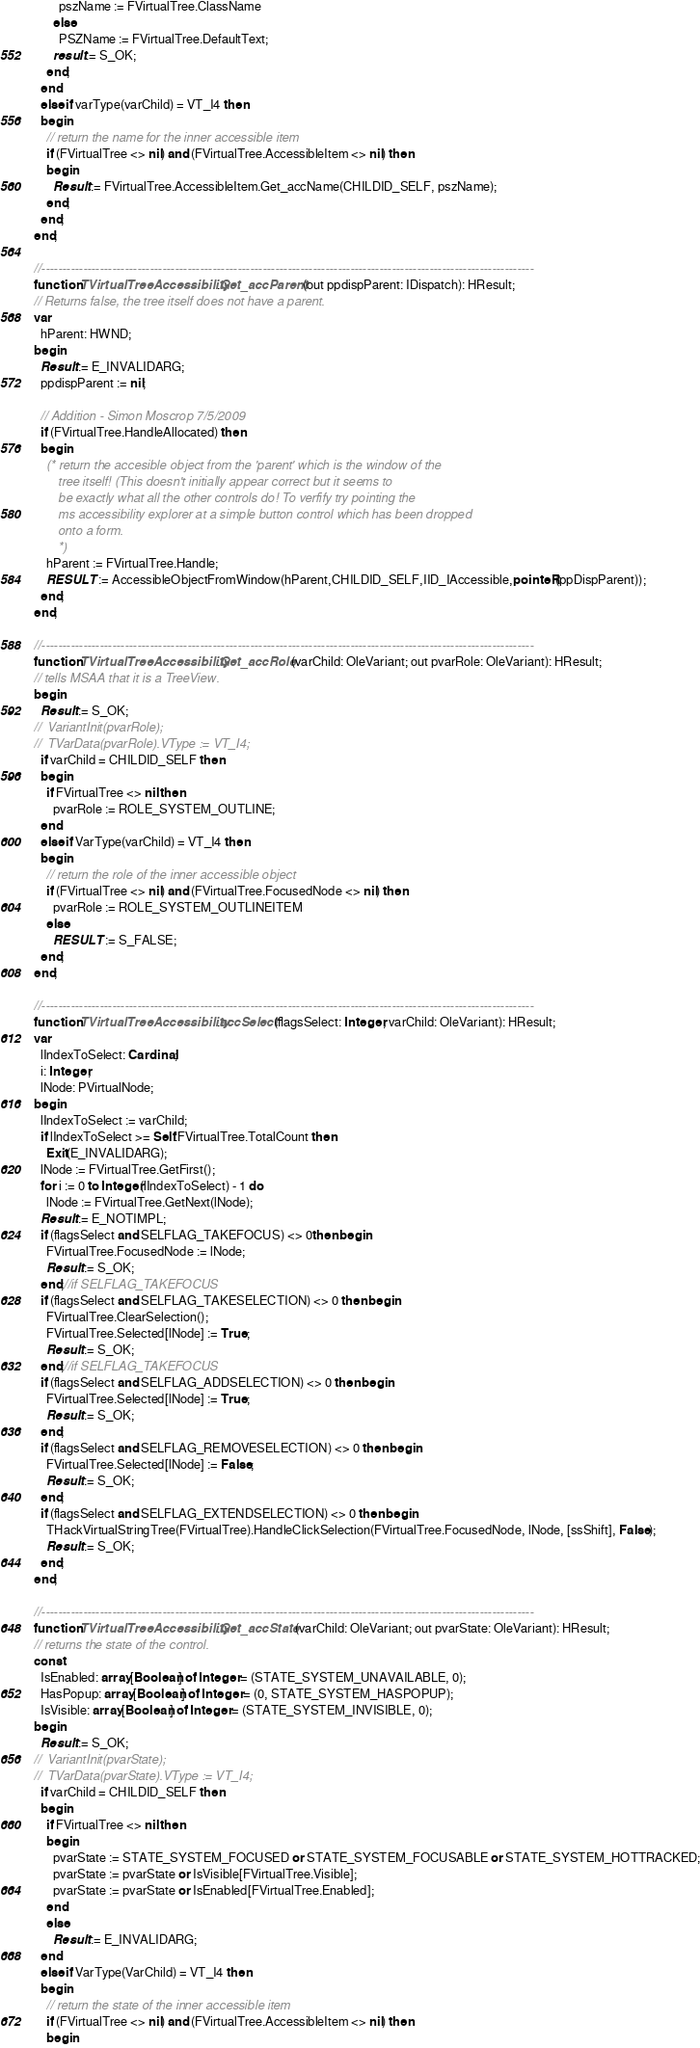<code> <loc_0><loc_0><loc_500><loc_500><_Pascal_>        pszName := FVirtualTree.ClassName
      else
        PSZName := FVirtualTree.DefaultText;
      result := S_OK;
    end;
  end
  else if varType(varChild) = VT_I4 then
  begin
    // return the name for the inner accessible item
    if (FVirtualTree <> nil) and (FVirtualTree.AccessibleItem <> nil) then
    begin
      Result := FVirtualTree.AccessibleItem.Get_accName(CHILDID_SELF, pszName);
    end;
  end;
end;

//----------------------------------------------------------------------------------------------------------------------
function TVirtualTreeAccessibility.Get_accParent(out ppdispParent: IDispatch): HResult;
// Returns false, the tree itself does not have a parent.
var
  hParent: HWND;
begin
  Result := E_INVALIDARG;
  ppdispParent := nil;

  // Addition - Simon Moscrop 7/5/2009
  if (FVirtualTree.HandleAllocated) then
  begin
    (* return the accesible object from the 'parent' which is the window of the
       tree itself! (This doesn't initially appear correct but it seems to
       be exactly what all the other controls do! To verfify try pointing the
       ms accessibility explorer at a simple button control which has been dropped
       onto a form.
       *)
    hParent := FVirtualTree.Handle;
    RESULT := AccessibleObjectFromWindow(hParent,CHILDID_SELF,IID_IAccessible,pointeR(ppDispParent));
  end;
end;

//----------------------------------------------------------------------------------------------------------------------
function TVirtualTreeAccessibility.Get_accRole(varChild: OleVariant; out pvarRole: OleVariant): HResult;
// tells MSAA that it is a TreeView.
begin
  Result := S_OK;
//  VariantInit(pvarRole);
//  TVarData(pvarRole).VType := VT_I4;
  if varChild = CHILDID_SELF then
  begin
    if FVirtualTree <> nil then
      pvarRole := ROLE_SYSTEM_OUTLINE;
  end
  else if VarType(varChild) = VT_I4 then
  begin
    // return the role of the inner accessible object
    if (FVirtualTree <> nil) and (FVirtualTree.FocusedNode <> nil) then
      pvarRole := ROLE_SYSTEM_OUTLINEITEM
    else
      RESULT := S_FALSE;
  end;
end;

//----------------------------------------------------------------------------------------------------------------------
function TVirtualTreeAccessibility.accSelect(flagsSelect: Integer; varChild: OleVariant): HResult;
var
  lIndexToSelect: Cardinal;
  i: Integer;
  lNode: PVirtualNode;
begin
  lIndexToSelect := varChild;
  if lIndexToSelect >= Self.FVirtualTree.TotalCount then
    Exit(E_INVALIDARG);
  lNode := FVirtualTree.GetFirst();
  for i := 0 to Integer(lIndexToSelect) - 1 do
    lNode := FVirtualTree.GetNext(lNode);
  Result := E_NOTIMPL;
  if (flagsSelect and SELFLAG_TAKEFOCUS) <> 0then begin
    FVirtualTree.FocusedNode := lNode;
    Result := S_OK;
  end;//if SELFLAG_TAKEFOCUS
  if (flagsSelect and SELFLAG_TAKESELECTION) <> 0 then begin
    FVirtualTree.ClearSelection();
    FVirtualTree.Selected[lNode] := True;
    Result := S_OK;
  end;//if SELFLAG_TAKEFOCUS
  if (flagsSelect and SELFLAG_ADDSELECTION) <> 0 then begin
    FVirtualTree.Selected[lNode] := True;
    Result := S_OK;
  end;
  if (flagsSelect and SELFLAG_REMOVESELECTION) <> 0 then begin
    FVirtualTree.Selected[lNode] := False;
    Result := S_OK;
  end;
  if (flagsSelect and SELFLAG_EXTENDSELECTION) <> 0 then begin
    THackVirtualStringTree(FVirtualTree).HandleClickSelection(FVirtualTree.FocusedNode, lNode, [ssShift], False);
    Result := S_OK;
  end;
end;

//----------------------------------------------------------------------------------------------------------------------
function TVirtualTreeAccessibility.Get_accState(varChild: OleVariant; out pvarState: OleVariant): HResult;
// returns the state of the control.
const
  IsEnabled: array[Boolean] of Integer = (STATE_SYSTEM_UNAVAILABLE, 0);
  HasPopup: array[Boolean] of Integer = (0, STATE_SYSTEM_HASPOPUP);
  IsVisible: array[Boolean] of Integer = (STATE_SYSTEM_INVISIBLE, 0);
begin
  Result := S_OK;
//  VariantInit(pvarState);
//  TVarData(pvarState).VType := VT_I4;
  if varChild = CHILDID_SELF then
  begin
    if FVirtualTree <> nil then
    begin
      pvarState := STATE_SYSTEM_FOCUSED or STATE_SYSTEM_FOCUSABLE or STATE_SYSTEM_HOTTRACKED;
      pvarState := pvarState or IsVisible[FVirtualTree.Visible];
      pvarState := pvarState or IsEnabled[FVirtualTree.Enabled];
    end
    else
      Result := E_INVALIDARG;
  end
  else if VarType(VarChild) = VT_I4 then
  begin
    // return the state of the inner accessible item
    if (FVirtualTree <> nil) and (FVirtualTree.AccessibleItem <> nil) then
    begin</code> 